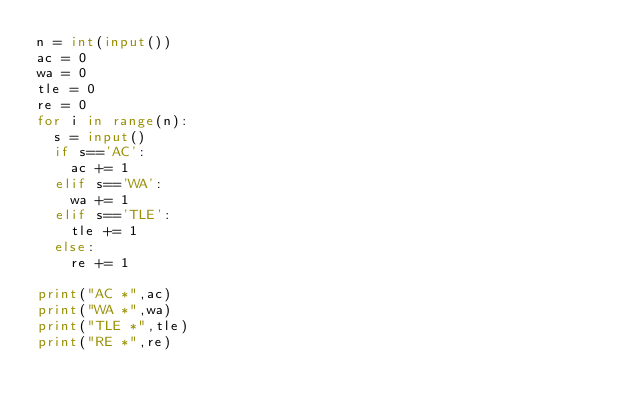Convert code to text. <code><loc_0><loc_0><loc_500><loc_500><_Python_>n = int(input())
ac = 0
wa = 0
tle = 0
re = 0
for i in range(n):
  s = input()
  if s=='AC':
    ac += 1
  elif s=='WA':
    wa += 1
  elif s=='TLE':
    tle += 1
  else:
    re += 1
    
print("AC *",ac)
print("WA *",wa)
print("TLE *",tle)
print("RE *",re)</code> 